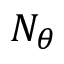<formula> <loc_0><loc_0><loc_500><loc_500>N _ { \theta }</formula> 